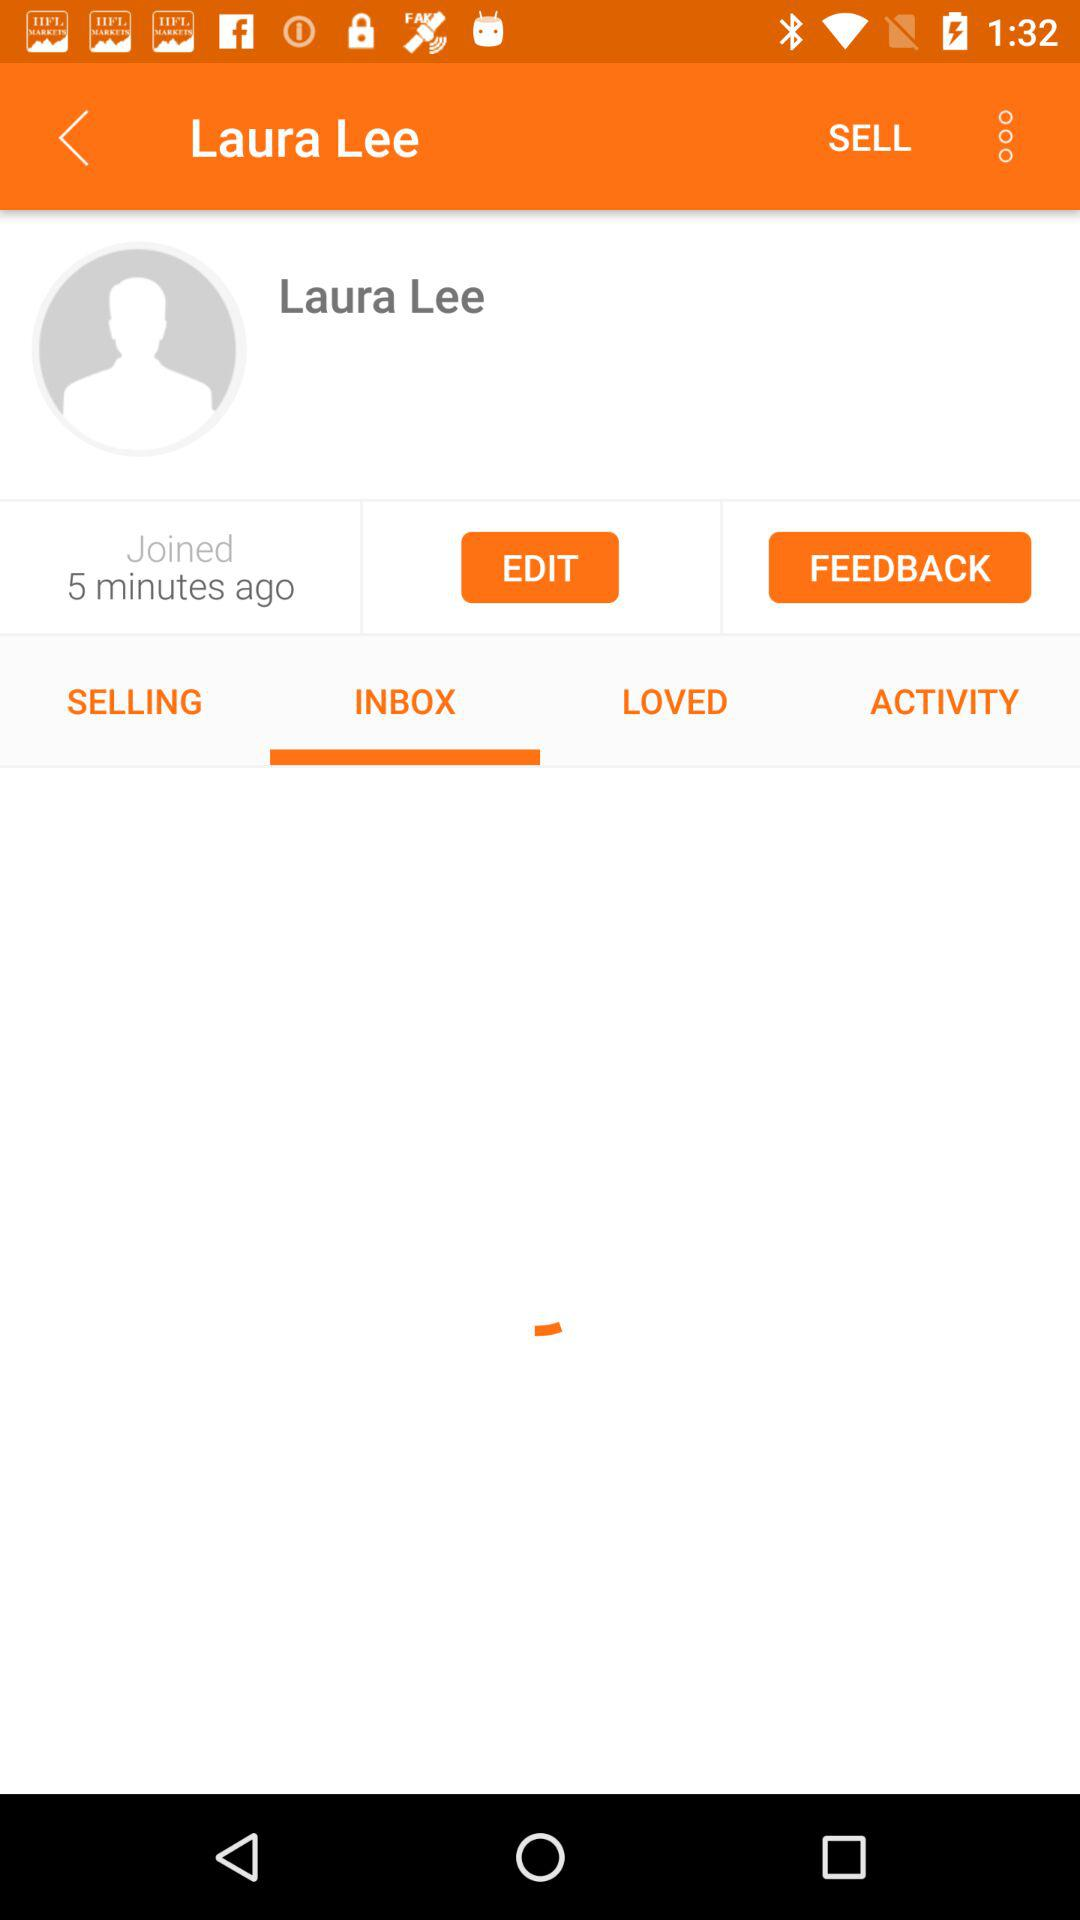How many minutes ago did the user join? The user joined 5 minutes ago. 